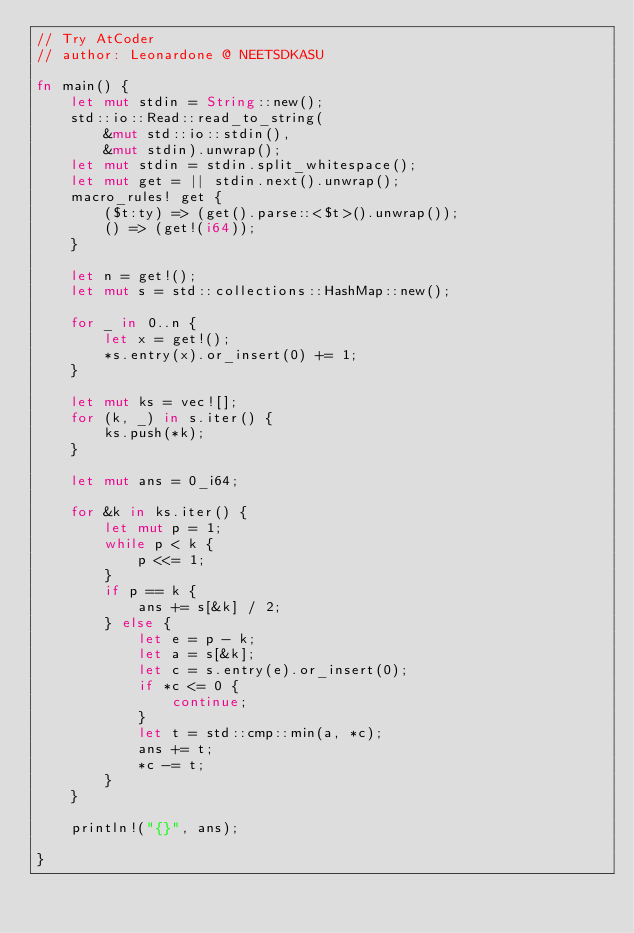<code> <loc_0><loc_0><loc_500><loc_500><_Rust_>// Try AtCoder
// author: Leonardone @ NEETSDKASU

fn main() {
	let mut stdin = String::new();
    std::io::Read::read_to_string(
    	&mut std::io::stdin(),
        &mut stdin).unwrap();
	let mut stdin = stdin.split_whitespace();
    let mut get = || stdin.next().unwrap();
    macro_rules! get {
    	($t:ty) => (get().parse::<$t>().unwrap());
        () => (get!(i64));
    }
    
    let n = get!();
    let mut s = std::collections::HashMap::new();
    
    for _ in 0..n {
    	let x = get!();
        *s.entry(x).or_insert(0) += 1;
    }
    
    let mut ks = vec![];
    for (k, _) in s.iter() {
    	ks.push(*k);
    }
    
    let mut ans = 0_i64;
    
    for &k in ks.iter() {
    	let mut p = 1;
        while p < k {
        	p <<= 1;
        }
        if p == k {
        	ans += s[&k] / 2;
        } else {
        	let e = p - k;
            let a = s[&k];
            let c = s.entry(e).or_insert(0);
            if *c <= 0 {
            	continue;
            }
            let t = std::cmp::min(a, *c);
            ans += t;
            *c -= t;
        }
    }
    
    println!("{}", ans);
    
}</code> 